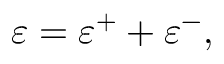<formula> <loc_0><loc_0><loc_500><loc_500>\varepsilon = \varepsilon ^ { + } + \varepsilon ^ { - } ,</formula> 